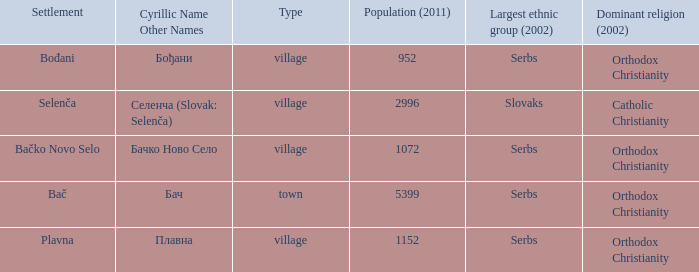What is the second way of writting плавна. Plavna. 